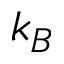Convert formula to latex. <formula><loc_0><loc_0><loc_500><loc_500>k _ { B }</formula> 